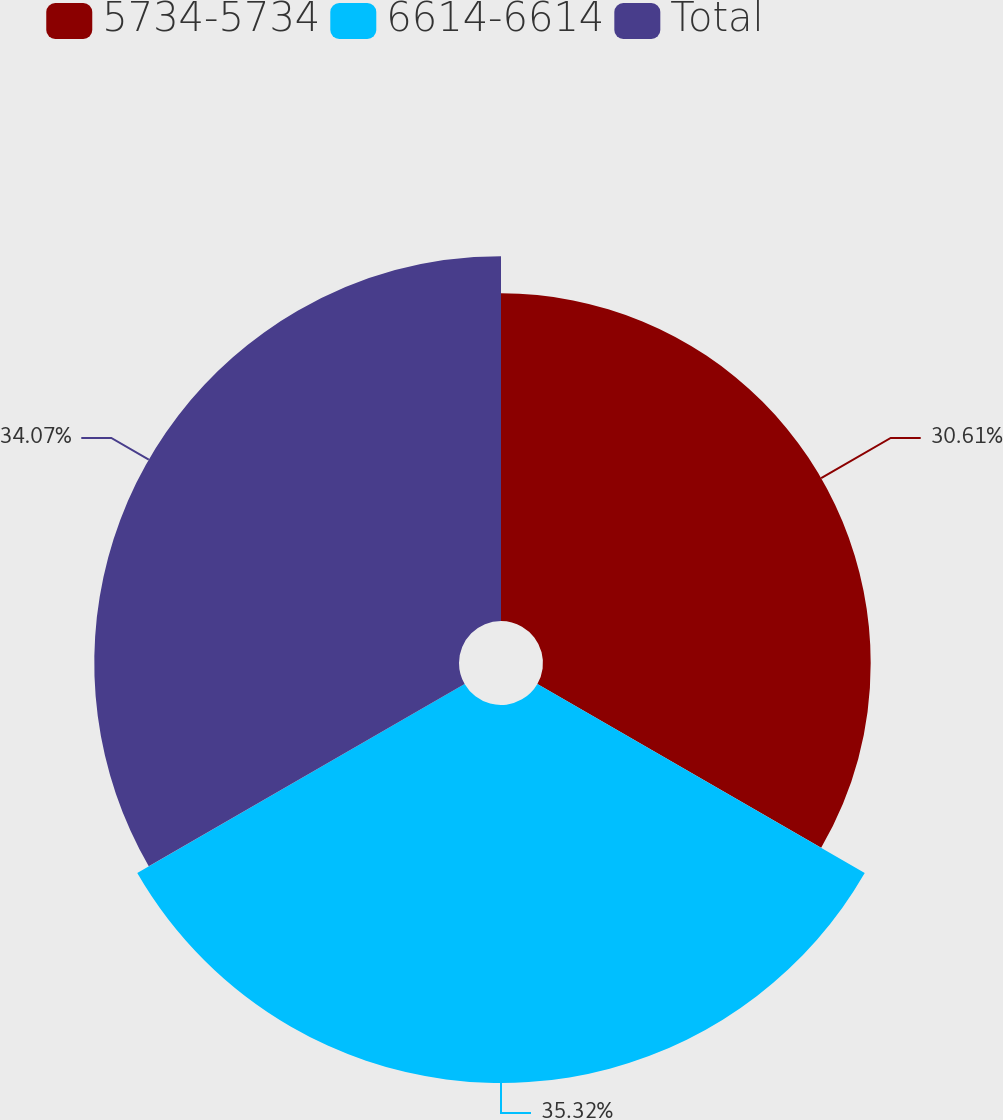Convert chart to OTSL. <chart><loc_0><loc_0><loc_500><loc_500><pie_chart><fcel>5734-5734<fcel>6614-6614<fcel>Total<nl><fcel>30.61%<fcel>35.31%<fcel>34.07%<nl></chart> 